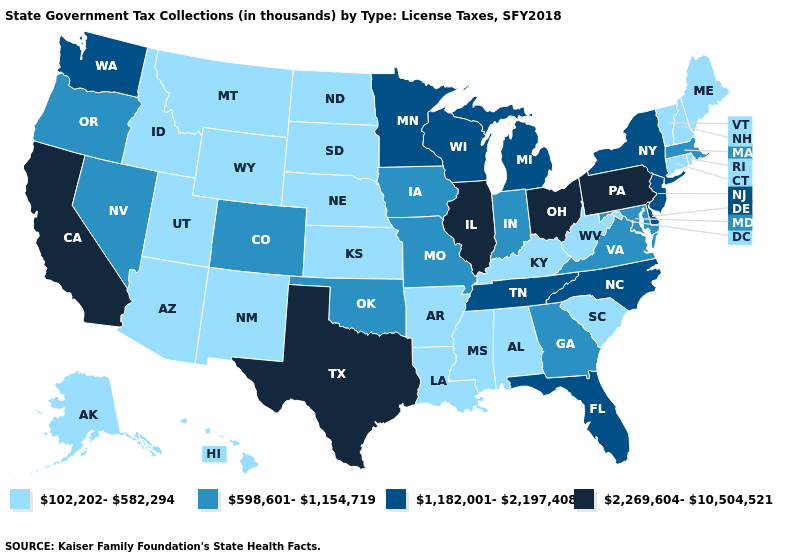What is the value of Maryland?
Concise answer only. 598,601-1,154,719. Does Georgia have the highest value in the South?
Short answer required. No. What is the value of Rhode Island?
Be succinct. 102,202-582,294. What is the lowest value in the USA?
Be succinct. 102,202-582,294. Name the states that have a value in the range 2,269,604-10,504,521?
Short answer required. California, Illinois, Ohio, Pennsylvania, Texas. Among the states that border Massachusetts , which have the highest value?
Write a very short answer. New York. What is the value of Virginia?
Concise answer only. 598,601-1,154,719. Does the first symbol in the legend represent the smallest category?
Concise answer only. Yes. Name the states that have a value in the range 1,182,001-2,197,408?
Quick response, please. Delaware, Florida, Michigan, Minnesota, New Jersey, New York, North Carolina, Tennessee, Washington, Wisconsin. What is the value of Connecticut?
Give a very brief answer. 102,202-582,294. Which states have the highest value in the USA?
Be succinct. California, Illinois, Ohio, Pennsylvania, Texas. Among the states that border Mississippi , which have the highest value?
Quick response, please. Tennessee. Does Minnesota have the lowest value in the MidWest?
Give a very brief answer. No. Among the states that border Utah , does Nevada have the highest value?
Concise answer only. Yes. Name the states that have a value in the range 2,269,604-10,504,521?
Answer briefly. California, Illinois, Ohio, Pennsylvania, Texas. 